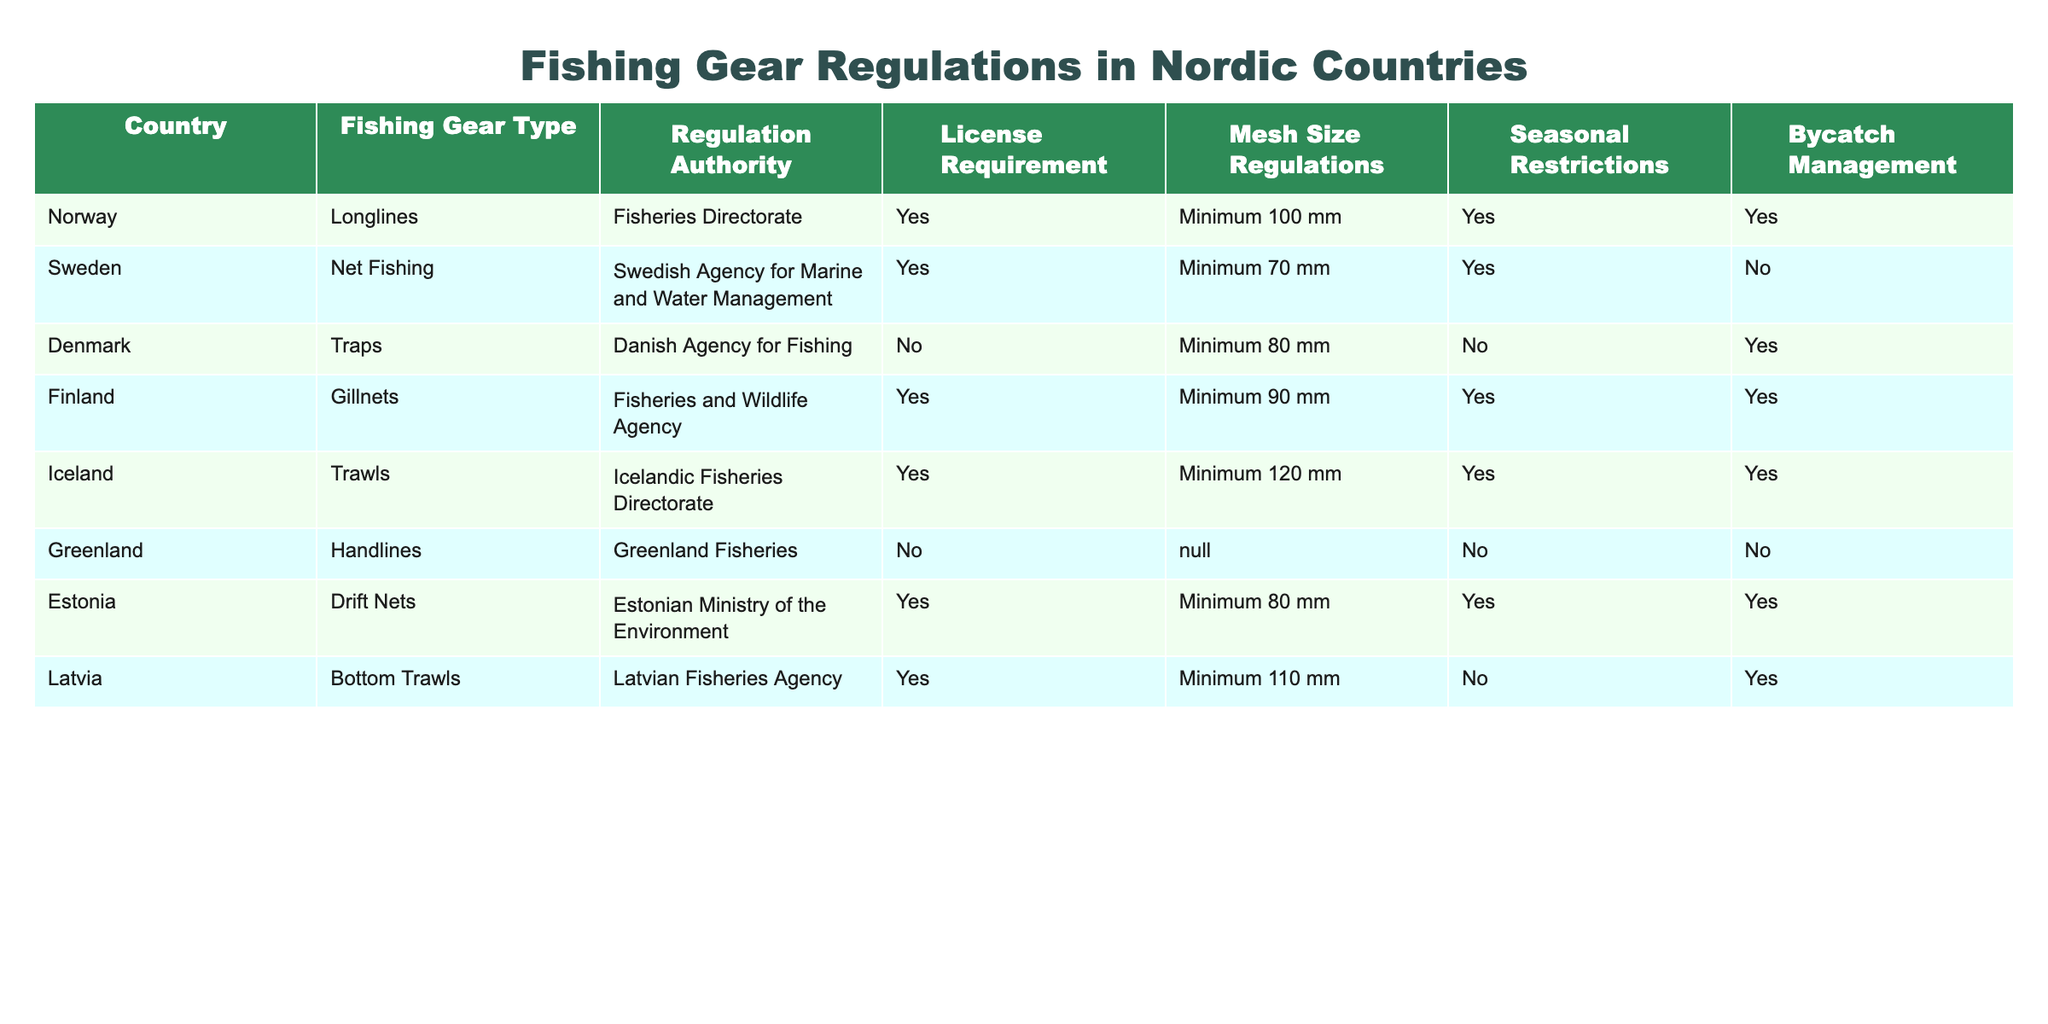What fishing gear type is used in Sweden? From the table, under the "Fishing Gear Type" column for the country "Sweden", it states "Net Fishing". This is a direct retrieval of the value associated with Sweden.
Answer: Net Fishing Which country requires a license for trap fishing? Looking at the "License Requirement" column, Denmark has "No" for Trap Fishing, while all other countries that use different types of gear (including traps) require a license. Thus, there is no country that requires a license specifically for trap fishing.
Answer: None Is the minimum mesh size for longlines in Norway larger than in Finland? The minimum mesh size for longlines in Norway is 100 mm, while for gillnets in Finland it's 90 mm. Since 100 mm is greater than 90 mm, this statement is true.
Answer: Yes What are the mesh size regulations for drift nets in Estonia? According to the table, the mesh size regulation for drift nets in Estonia is "Minimum 80 mm", which can be found directly in the respective row for Estonia.
Answer: Minimum 80 mm Which countries have seasonal restrictions for fishing gear? From the table, Norway, Finland, Iceland, and Estonia all have "Yes" under "Seasonal Restrictions". Therefore, these countries impose seasonal restrictions for fishing gear.
Answer: Norway, Finland, Iceland, Estonia How many countries do not require a license for fishing gear? By reviewing the "License Requirement" column, we see that Denmark and Greenland have "No" for their respective fishing gear. Counting these entries gives us 2 countries that do not require a license.
Answer: 2 Which fishing gear type in Iceland has the highest minimum mesh size requirement? In Iceland, the fishing gear type "Trawls" has a minimum mesh size requirement of "Minimum 120 mm"; examining the entire table, this is indeed the highest value listed for mesh size requirements for fishing gear types.
Answer: Trawls Are there any countries where bycatch management is not required? In the "Bycatch Management" column, Denmark and Greenland are listed as having "No" for bycatch management, which indicates they do not require bycatch management.
Answer: Yes, Denmark and Greenland Which country has the most stringent mesh size regulation among all listed countries? The comparison across all minimum mesh sizes shows that Iceland's minimum mesh size of 120 mm is the highest, signifying it as the most stringent regulation among the listed countries.
Answer: Iceland 